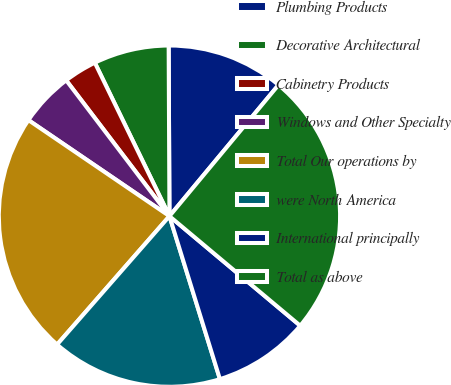Convert chart. <chart><loc_0><loc_0><loc_500><loc_500><pie_chart><fcel>Plumbing Products<fcel>Decorative Architectural<fcel>Cabinetry Products<fcel>Windows and Other Specialty<fcel>Total Our operations by<fcel>were North America<fcel>International principally<fcel>Total as above<nl><fcel>11.11%<fcel>7.13%<fcel>3.14%<fcel>5.14%<fcel>23.07%<fcel>16.22%<fcel>9.12%<fcel>25.06%<nl></chart> 